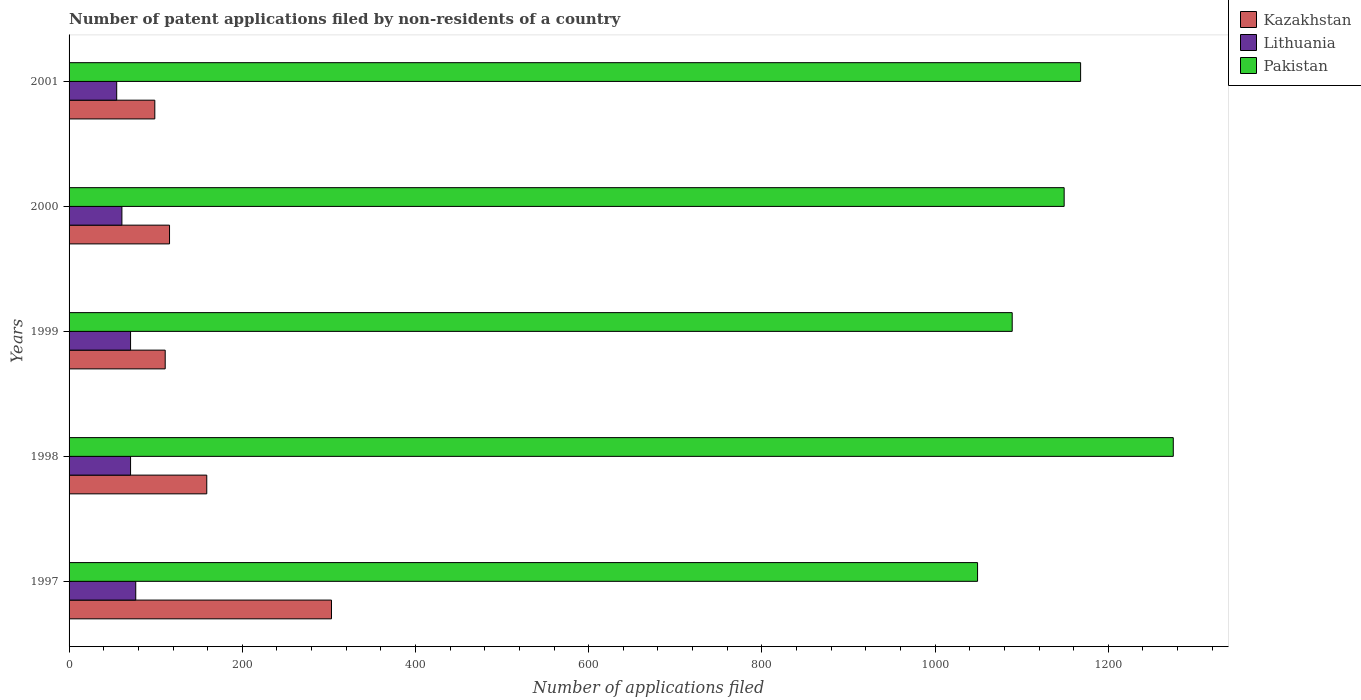How many different coloured bars are there?
Provide a succinct answer. 3. Are the number of bars on each tick of the Y-axis equal?
Your response must be concise. Yes. How many bars are there on the 2nd tick from the top?
Give a very brief answer. 3. In how many cases, is the number of bars for a given year not equal to the number of legend labels?
Offer a very short reply. 0. What is the number of applications filed in Kazakhstan in 2000?
Your response must be concise. 116. Across all years, what is the maximum number of applications filed in Pakistan?
Your answer should be very brief. 1275. Across all years, what is the minimum number of applications filed in Pakistan?
Give a very brief answer. 1049. In which year was the number of applications filed in Pakistan maximum?
Provide a short and direct response. 1998. What is the total number of applications filed in Kazakhstan in the graph?
Your response must be concise. 788. What is the difference between the number of applications filed in Pakistan in 1999 and that in 2000?
Offer a terse response. -60. What is the difference between the number of applications filed in Pakistan in 2000 and the number of applications filed in Kazakhstan in 2001?
Ensure brevity in your answer.  1050. What is the average number of applications filed in Pakistan per year?
Your answer should be very brief. 1146. In the year 1998, what is the difference between the number of applications filed in Lithuania and number of applications filed in Kazakhstan?
Ensure brevity in your answer.  -88. What is the ratio of the number of applications filed in Lithuania in 1997 to that in 1999?
Keep it short and to the point. 1.08. What is the difference between the highest and the second highest number of applications filed in Lithuania?
Make the answer very short. 6. What is the difference between the highest and the lowest number of applications filed in Pakistan?
Provide a succinct answer. 226. What does the 1st bar from the top in 2001 represents?
Your answer should be compact. Pakistan. What does the 2nd bar from the bottom in 1998 represents?
Make the answer very short. Lithuania. How many bars are there?
Your answer should be compact. 15. Are all the bars in the graph horizontal?
Your response must be concise. Yes. What is the difference between two consecutive major ticks on the X-axis?
Keep it short and to the point. 200. Does the graph contain any zero values?
Provide a succinct answer. No. Does the graph contain grids?
Offer a very short reply. No. Where does the legend appear in the graph?
Provide a short and direct response. Top right. How are the legend labels stacked?
Your answer should be compact. Vertical. What is the title of the graph?
Offer a terse response. Number of patent applications filed by non-residents of a country. Does "Andorra" appear as one of the legend labels in the graph?
Offer a very short reply. No. What is the label or title of the X-axis?
Ensure brevity in your answer.  Number of applications filed. What is the label or title of the Y-axis?
Your answer should be very brief. Years. What is the Number of applications filed of Kazakhstan in 1997?
Your answer should be very brief. 303. What is the Number of applications filed of Lithuania in 1997?
Your answer should be compact. 77. What is the Number of applications filed in Pakistan in 1997?
Provide a succinct answer. 1049. What is the Number of applications filed of Kazakhstan in 1998?
Your answer should be very brief. 159. What is the Number of applications filed in Pakistan in 1998?
Ensure brevity in your answer.  1275. What is the Number of applications filed in Kazakhstan in 1999?
Give a very brief answer. 111. What is the Number of applications filed in Lithuania in 1999?
Offer a terse response. 71. What is the Number of applications filed in Pakistan in 1999?
Provide a short and direct response. 1089. What is the Number of applications filed in Kazakhstan in 2000?
Keep it short and to the point. 116. What is the Number of applications filed in Pakistan in 2000?
Offer a terse response. 1149. What is the Number of applications filed of Kazakhstan in 2001?
Make the answer very short. 99. What is the Number of applications filed of Pakistan in 2001?
Offer a very short reply. 1168. Across all years, what is the maximum Number of applications filed in Kazakhstan?
Provide a succinct answer. 303. Across all years, what is the maximum Number of applications filed of Pakistan?
Your answer should be very brief. 1275. Across all years, what is the minimum Number of applications filed in Lithuania?
Provide a short and direct response. 55. Across all years, what is the minimum Number of applications filed of Pakistan?
Your answer should be compact. 1049. What is the total Number of applications filed in Kazakhstan in the graph?
Ensure brevity in your answer.  788. What is the total Number of applications filed in Lithuania in the graph?
Your answer should be very brief. 335. What is the total Number of applications filed in Pakistan in the graph?
Keep it short and to the point. 5730. What is the difference between the Number of applications filed of Kazakhstan in 1997 and that in 1998?
Your answer should be compact. 144. What is the difference between the Number of applications filed of Pakistan in 1997 and that in 1998?
Provide a short and direct response. -226. What is the difference between the Number of applications filed in Kazakhstan in 1997 and that in 1999?
Ensure brevity in your answer.  192. What is the difference between the Number of applications filed in Lithuania in 1997 and that in 1999?
Your answer should be very brief. 6. What is the difference between the Number of applications filed in Kazakhstan in 1997 and that in 2000?
Ensure brevity in your answer.  187. What is the difference between the Number of applications filed in Lithuania in 1997 and that in 2000?
Your answer should be compact. 16. What is the difference between the Number of applications filed in Pakistan in 1997 and that in 2000?
Provide a short and direct response. -100. What is the difference between the Number of applications filed of Kazakhstan in 1997 and that in 2001?
Your response must be concise. 204. What is the difference between the Number of applications filed of Lithuania in 1997 and that in 2001?
Offer a very short reply. 22. What is the difference between the Number of applications filed in Pakistan in 1997 and that in 2001?
Give a very brief answer. -119. What is the difference between the Number of applications filed in Kazakhstan in 1998 and that in 1999?
Your answer should be compact. 48. What is the difference between the Number of applications filed of Lithuania in 1998 and that in 1999?
Your answer should be very brief. 0. What is the difference between the Number of applications filed in Pakistan in 1998 and that in 1999?
Your response must be concise. 186. What is the difference between the Number of applications filed in Lithuania in 1998 and that in 2000?
Your response must be concise. 10. What is the difference between the Number of applications filed of Pakistan in 1998 and that in 2000?
Offer a terse response. 126. What is the difference between the Number of applications filed of Lithuania in 1998 and that in 2001?
Keep it short and to the point. 16. What is the difference between the Number of applications filed of Pakistan in 1998 and that in 2001?
Your response must be concise. 107. What is the difference between the Number of applications filed of Kazakhstan in 1999 and that in 2000?
Your answer should be very brief. -5. What is the difference between the Number of applications filed of Pakistan in 1999 and that in 2000?
Offer a very short reply. -60. What is the difference between the Number of applications filed of Kazakhstan in 1999 and that in 2001?
Give a very brief answer. 12. What is the difference between the Number of applications filed of Lithuania in 1999 and that in 2001?
Your answer should be very brief. 16. What is the difference between the Number of applications filed of Pakistan in 1999 and that in 2001?
Give a very brief answer. -79. What is the difference between the Number of applications filed of Pakistan in 2000 and that in 2001?
Your answer should be compact. -19. What is the difference between the Number of applications filed in Kazakhstan in 1997 and the Number of applications filed in Lithuania in 1998?
Offer a terse response. 232. What is the difference between the Number of applications filed of Kazakhstan in 1997 and the Number of applications filed of Pakistan in 1998?
Your response must be concise. -972. What is the difference between the Number of applications filed in Lithuania in 1997 and the Number of applications filed in Pakistan in 1998?
Offer a terse response. -1198. What is the difference between the Number of applications filed in Kazakhstan in 1997 and the Number of applications filed in Lithuania in 1999?
Give a very brief answer. 232. What is the difference between the Number of applications filed of Kazakhstan in 1997 and the Number of applications filed of Pakistan in 1999?
Your answer should be very brief. -786. What is the difference between the Number of applications filed in Lithuania in 1997 and the Number of applications filed in Pakistan in 1999?
Your response must be concise. -1012. What is the difference between the Number of applications filed in Kazakhstan in 1997 and the Number of applications filed in Lithuania in 2000?
Your answer should be very brief. 242. What is the difference between the Number of applications filed in Kazakhstan in 1997 and the Number of applications filed in Pakistan in 2000?
Provide a succinct answer. -846. What is the difference between the Number of applications filed of Lithuania in 1997 and the Number of applications filed of Pakistan in 2000?
Your answer should be very brief. -1072. What is the difference between the Number of applications filed in Kazakhstan in 1997 and the Number of applications filed in Lithuania in 2001?
Make the answer very short. 248. What is the difference between the Number of applications filed in Kazakhstan in 1997 and the Number of applications filed in Pakistan in 2001?
Ensure brevity in your answer.  -865. What is the difference between the Number of applications filed of Lithuania in 1997 and the Number of applications filed of Pakistan in 2001?
Offer a terse response. -1091. What is the difference between the Number of applications filed of Kazakhstan in 1998 and the Number of applications filed of Pakistan in 1999?
Your answer should be compact. -930. What is the difference between the Number of applications filed of Lithuania in 1998 and the Number of applications filed of Pakistan in 1999?
Your answer should be very brief. -1018. What is the difference between the Number of applications filed of Kazakhstan in 1998 and the Number of applications filed of Pakistan in 2000?
Keep it short and to the point. -990. What is the difference between the Number of applications filed of Lithuania in 1998 and the Number of applications filed of Pakistan in 2000?
Ensure brevity in your answer.  -1078. What is the difference between the Number of applications filed of Kazakhstan in 1998 and the Number of applications filed of Lithuania in 2001?
Keep it short and to the point. 104. What is the difference between the Number of applications filed of Kazakhstan in 1998 and the Number of applications filed of Pakistan in 2001?
Make the answer very short. -1009. What is the difference between the Number of applications filed in Lithuania in 1998 and the Number of applications filed in Pakistan in 2001?
Make the answer very short. -1097. What is the difference between the Number of applications filed in Kazakhstan in 1999 and the Number of applications filed in Pakistan in 2000?
Your response must be concise. -1038. What is the difference between the Number of applications filed in Lithuania in 1999 and the Number of applications filed in Pakistan in 2000?
Ensure brevity in your answer.  -1078. What is the difference between the Number of applications filed of Kazakhstan in 1999 and the Number of applications filed of Pakistan in 2001?
Ensure brevity in your answer.  -1057. What is the difference between the Number of applications filed of Lithuania in 1999 and the Number of applications filed of Pakistan in 2001?
Make the answer very short. -1097. What is the difference between the Number of applications filed of Kazakhstan in 2000 and the Number of applications filed of Pakistan in 2001?
Offer a terse response. -1052. What is the difference between the Number of applications filed in Lithuania in 2000 and the Number of applications filed in Pakistan in 2001?
Your answer should be very brief. -1107. What is the average Number of applications filed in Kazakhstan per year?
Your answer should be very brief. 157.6. What is the average Number of applications filed of Pakistan per year?
Ensure brevity in your answer.  1146. In the year 1997, what is the difference between the Number of applications filed in Kazakhstan and Number of applications filed in Lithuania?
Provide a short and direct response. 226. In the year 1997, what is the difference between the Number of applications filed in Kazakhstan and Number of applications filed in Pakistan?
Offer a terse response. -746. In the year 1997, what is the difference between the Number of applications filed of Lithuania and Number of applications filed of Pakistan?
Your response must be concise. -972. In the year 1998, what is the difference between the Number of applications filed of Kazakhstan and Number of applications filed of Lithuania?
Ensure brevity in your answer.  88. In the year 1998, what is the difference between the Number of applications filed in Kazakhstan and Number of applications filed in Pakistan?
Your response must be concise. -1116. In the year 1998, what is the difference between the Number of applications filed of Lithuania and Number of applications filed of Pakistan?
Your response must be concise. -1204. In the year 1999, what is the difference between the Number of applications filed in Kazakhstan and Number of applications filed in Pakistan?
Offer a very short reply. -978. In the year 1999, what is the difference between the Number of applications filed of Lithuania and Number of applications filed of Pakistan?
Your answer should be very brief. -1018. In the year 2000, what is the difference between the Number of applications filed in Kazakhstan and Number of applications filed in Pakistan?
Offer a terse response. -1033. In the year 2000, what is the difference between the Number of applications filed in Lithuania and Number of applications filed in Pakistan?
Ensure brevity in your answer.  -1088. In the year 2001, what is the difference between the Number of applications filed in Kazakhstan and Number of applications filed in Pakistan?
Keep it short and to the point. -1069. In the year 2001, what is the difference between the Number of applications filed of Lithuania and Number of applications filed of Pakistan?
Provide a succinct answer. -1113. What is the ratio of the Number of applications filed of Kazakhstan in 1997 to that in 1998?
Your response must be concise. 1.91. What is the ratio of the Number of applications filed of Lithuania in 1997 to that in 1998?
Keep it short and to the point. 1.08. What is the ratio of the Number of applications filed in Pakistan in 1997 to that in 1998?
Give a very brief answer. 0.82. What is the ratio of the Number of applications filed of Kazakhstan in 1997 to that in 1999?
Provide a short and direct response. 2.73. What is the ratio of the Number of applications filed in Lithuania in 1997 to that in 1999?
Give a very brief answer. 1.08. What is the ratio of the Number of applications filed of Pakistan in 1997 to that in 1999?
Offer a very short reply. 0.96. What is the ratio of the Number of applications filed in Kazakhstan in 1997 to that in 2000?
Keep it short and to the point. 2.61. What is the ratio of the Number of applications filed in Lithuania in 1997 to that in 2000?
Offer a terse response. 1.26. What is the ratio of the Number of applications filed in Kazakhstan in 1997 to that in 2001?
Your answer should be very brief. 3.06. What is the ratio of the Number of applications filed in Lithuania in 1997 to that in 2001?
Your answer should be compact. 1.4. What is the ratio of the Number of applications filed in Pakistan in 1997 to that in 2001?
Provide a short and direct response. 0.9. What is the ratio of the Number of applications filed of Kazakhstan in 1998 to that in 1999?
Keep it short and to the point. 1.43. What is the ratio of the Number of applications filed of Pakistan in 1998 to that in 1999?
Provide a succinct answer. 1.17. What is the ratio of the Number of applications filed of Kazakhstan in 1998 to that in 2000?
Your answer should be very brief. 1.37. What is the ratio of the Number of applications filed of Lithuania in 1998 to that in 2000?
Your answer should be compact. 1.16. What is the ratio of the Number of applications filed in Pakistan in 1998 to that in 2000?
Offer a terse response. 1.11. What is the ratio of the Number of applications filed in Kazakhstan in 1998 to that in 2001?
Give a very brief answer. 1.61. What is the ratio of the Number of applications filed in Lithuania in 1998 to that in 2001?
Provide a succinct answer. 1.29. What is the ratio of the Number of applications filed of Pakistan in 1998 to that in 2001?
Offer a terse response. 1.09. What is the ratio of the Number of applications filed in Kazakhstan in 1999 to that in 2000?
Ensure brevity in your answer.  0.96. What is the ratio of the Number of applications filed of Lithuania in 1999 to that in 2000?
Provide a succinct answer. 1.16. What is the ratio of the Number of applications filed of Pakistan in 1999 to that in 2000?
Your answer should be very brief. 0.95. What is the ratio of the Number of applications filed of Kazakhstan in 1999 to that in 2001?
Your answer should be compact. 1.12. What is the ratio of the Number of applications filed of Lithuania in 1999 to that in 2001?
Give a very brief answer. 1.29. What is the ratio of the Number of applications filed in Pakistan in 1999 to that in 2001?
Offer a very short reply. 0.93. What is the ratio of the Number of applications filed in Kazakhstan in 2000 to that in 2001?
Keep it short and to the point. 1.17. What is the ratio of the Number of applications filed of Lithuania in 2000 to that in 2001?
Give a very brief answer. 1.11. What is the ratio of the Number of applications filed of Pakistan in 2000 to that in 2001?
Provide a succinct answer. 0.98. What is the difference between the highest and the second highest Number of applications filed of Kazakhstan?
Provide a succinct answer. 144. What is the difference between the highest and the second highest Number of applications filed of Lithuania?
Keep it short and to the point. 6. What is the difference between the highest and the second highest Number of applications filed in Pakistan?
Your response must be concise. 107. What is the difference between the highest and the lowest Number of applications filed in Kazakhstan?
Provide a short and direct response. 204. What is the difference between the highest and the lowest Number of applications filed of Lithuania?
Your response must be concise. 22. What is the difference between the highest and the lowest Number of applications filed in Pakistan?
Ensure brevity in your answer.  226. 